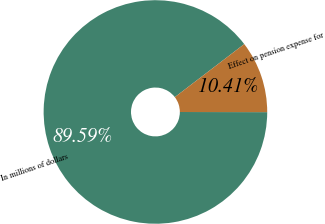Convert chart to OTSL. <chart><loc_0><loc_0><loc_500><loc_500><pie_chart><fcel>In millions of dollars<fcel>Effect on pension expense for<nl><fcel>89.59%<fcel>10.41%<nl></chart> 